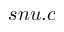<formula> <loc_0><loc_0><loc_500><loc_500>s n u . c</formula> 